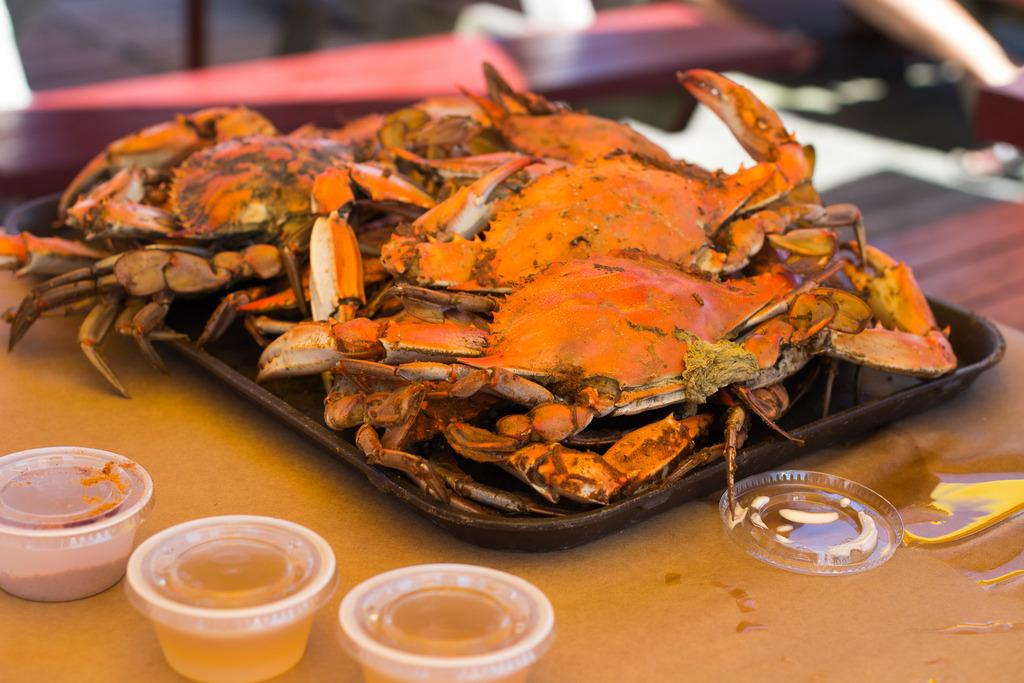What is located at the bottom of the image? There is a table at the bottom of the image. What type of seafood can be seen on the table? There are crabs on the table. What is used to hold or serve items on the table? There is a tray on the table. What are the containers for holding food on the table? There are bowls on the table. What is used to add flavor to the food on the table? There is sauce on the table. How does the stitch hold the crabs together in the image? There is no stitch present in the image. --- Facts: 1. There is a person in the image. 2. The person is wearing a hat. 3. The person is holding a book. 4. The person is sitting on a chair. 5. There is a lamp in the image. Absurd Topics: unicorn, parachute, dance Conversation: Who or what is present in the image? There is a person in the image. What is the person wearing in the image? The person is wearing a hat. What is the person holding in the image? The person is holding a book. What is the person doing in the image? The person is sitting on a chair. What is the additional object in the image? There is a lamp in the image. Reasoning: Let's think step by step in order to produce the conversation. We start by identifying the main subject of the image, which is the person. Then, we describe the person's attire, actions, and any additional objects in the image. Each question is designed to elicit a specific detail about the image that is known from the provided facts. Absurd Question/Answer: Can you see a unicorn in the image? There is no unicorn present in the image. --- Facts: 1. There is a dog in the image. 2. The dog is lying down on the grass. 3. There is a tree in the background. 4. The sky is visible in the image. 5. There is a ball near the dog. Absurd Topics: spaceship, rocket, fly Conversation: What type of animal is present in the image? There is a dog in the image. What is the dog doing in the image? The dog is lying down on the grass. What can be seen in the background of the image? There is a tree in the background. What is visible in the sky in the image? The sky is visible in the image. What object is near the dog in the image? There is a ball near the dog. Reasoning: Let's think step by step in order to produce the conversation. We start by identifying the main subject of the image, which is the dog. Then, we describe 